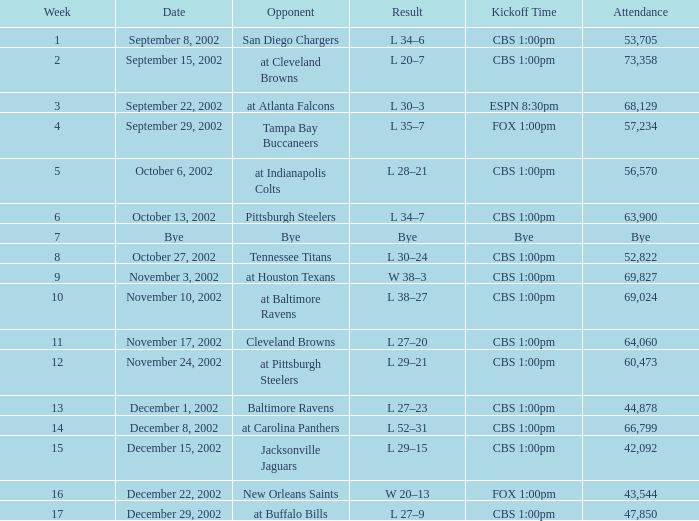How many attendees were there at the event with a kickoff at cbs 1:00pm, in a week preceding 8, on september 15, 2002? 73358.0. 